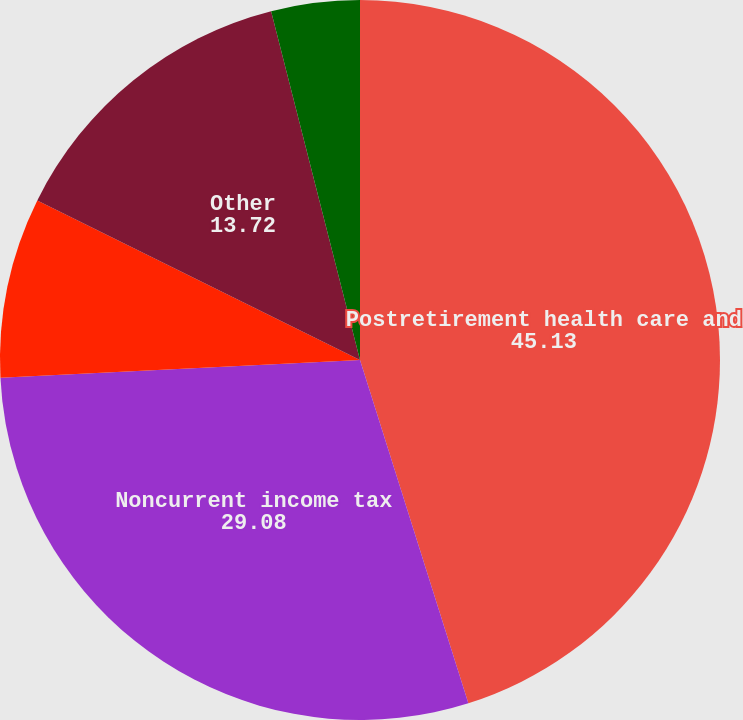<chart> <loc_0><loc_0><loc_500><loc_500><pie_chart><fcel>Postretirement health care and<fcel>Noncurrent income tax<fcel>Environmental liabilities<fcel>Other<fcel>Less current portion<nl><fcel>45.13%<fcel>29.08%<fcel>8.09%<fcel>13.72%<fcel>3.97%<nl></chart> 